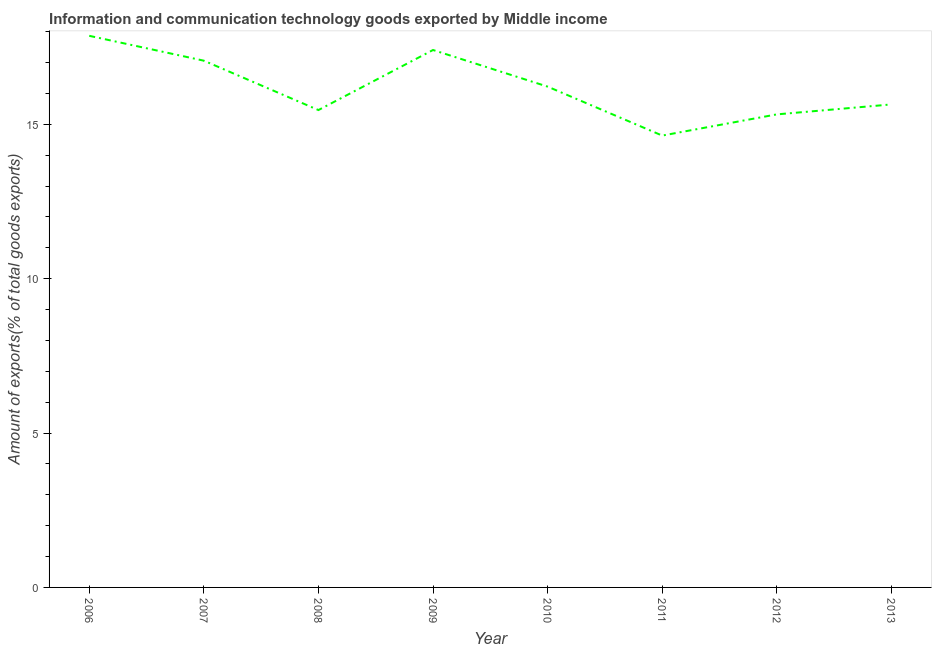What is the amount of ict goods exports in 2012?
Ensure brevity in your answer.  15.32. Across all years, what is the maximum amount of ict goods exports?
Make the answer very short. 17.86. Across all years, what is the minimum amount of ict goods exports?
Provide a succinct answer. 14.63. In which year was the amount of ict goods exports minimum?
Provide a succinct answer. 2011. What is the sum of the amount of ict goods exports?
Offer a very short reply. 129.61. What is the difference between the amount of ict goods exports in 2006 and 2010?
Keep it short and to the point. 1.65. What is the average amount of ict goods exports per year?
Your answer should be very brief. 16.2. What is the median amount of ict goods exports?
Provide a succinct answer. 15.93. Do a majority of the years between 2009 and 2012 (inclusive) have amount of ict goods exports greater than 7 %?
Offer a very short reply. Yes. What is the ratio of the amount of ict goods exports in 2008 to that in 2011?
Offer a very short reply. 1.06. Is the difference between the amount of ict goods exports in 2006 and 2012 greater than the difference between any two years?
Offer a very short reply. No. What is the difference between the highest and the second highest amount of ict goods exports?
Your response must be concise. 0.46. Is the sum of the amount of ict goods exports in 2010 and 2013 greater than the maximum amount of ict goods exports across all years?
Provide a short and direct response. Yes. What is the difference between the highest and the lowest amount of ict goods exports?
Your response must be concise. 3.23. In how many years, is the amount of ict goods exports greater than the average amount of ict goods exports taken over all years?
Ensure brevity in your answer.  4. Does the amount of ict goods exports monotonically increase over the years?
Your response must be concise. No. How many years are there in the graph?
Ensure brevity in your answer.  8. What is the difference between two consecutive major ticks on the Y-axis?
Provide a succinct answer. 5. Does the graph contain any zero values?
Offer a very short reply. No. What is the title of the graph?
Keep it short and to the point. Information and communication technology goods exported by Middle income. What is the label or title of the X-axis?
Offer a very short reply. Year. What is the label or title of the Y-axis?
Provide a short and direct response. Amount of exports(% of total goods exports). What is the Amount of exports(% of total goods exports) in 2006?
Provide a short and direct response. 17.86. What is the Amount of exports(% of total goods exports) in 2007?
Offer a terse response. 17.06. What is the Amount of exports(% of total goods exports) in 2008?
Offer a very short reply. 15.46. What is the Amount of exports(% of total goods exports) in 2009?
Provide a short and direct response. 17.41. What is the Amount of exports(% of total goods exports) in 2010?
Your response must be concise. 16.22. What is the Amount of exports(% of total goods exports) in 2011?
Give a very brief answer. 14.63. What is the Amount of exports(% of total goods exports) of 2012?
Your answer should be compact. 15.32. What is the Amount of exports(% of total goods exports) of 2013?
Make the answer very short. 15.64. What is the difference between the Amount of exports(% of total goods exports) in 2006 and 2007?
Ensure brevity in your answer.  0.81. What is the difference between the Amount of exports(% of total goods exports) in 2006 and 2008?
Your answer should be compact. 2.4. What is the difference between the Amount of exports(% of total goods exports) in 2006 and 2009?
Provide a short and direct response. 0.46. What is the difference between the Amount of exports(% of total goods exports) in 2006 and 2010?
Your answer should be very brief. 1.65. What is the difference between the Amount of exports(% of total goods exports) in 2006 and 2011?
Offer a terse response. 3.23. What is the difference between the Amount of exports(% of total goods exports) in 2006 and 2012?
Make the answer very short. 2.54. What is the difference between the Amount of exports(% of total goods exports) in 2006 and 2013?
Your answer should be compact. 2.22. What is the difference between the Amount of exports(% of total goods exports) in 2007 and 2008?
Give a very brief answer. 1.6. What is the difference between the Amount of exports(% of total goods exports) in 2007 and 2009?
Provide a short and direct response. -0.35. What is the difference between the Amount of exports(% of total goods exports) in 2007 and 2010?
Provide a short and direct response. 0.84. What is the difference between the Amount of exports(% of total goods exports) in 2007 and 2011?
Provide a succinct answer. 2.43. What is the difference between the Amount of exports(% of total goods exports) in 2007 and 2012?
Ensure brevity in your answer.  1.74. What is the difference between the Amount of exports(% of total goods exports) in 2007 and 2013?
Give a very brief answer. 1.42. What is the difference between the Amount of exports(% of total goods exports) in 2008 and 2009?
Ensure brevity in your answer.  -1.94. What is the difference between the Amount of exports(% of total goods exports) in 2008 and 2010?
Your answer should be very brief. -0.76. What is the difference between the Amount of exports(% of total goods exports) in 2008 and 2011?
Give a very brief answer. 0.83. What is the difference between the Amount of exports(% of total goods exports) in 2008 and 2012?
Provide a short and direct response. 0.14. What is the difference between the Amount of exports(% of total goods exports) in 2008 and 2013?
Your response must be concise. -0.18. What is the difference between the Amount of exports(% of total goods exports) in 2009 and 2010?
Ensure brevity in your answer.  1.19. What is the difference between the Amount of exports(% of total goods exports) in 2009 and 2011?
Make the answer very short. 2.77. What is the difference between the Amount of exports(% of total goods exports) in 2009 and 2012?
Make the answer very short. 2.09. What is the difference between the Amount of exports(% of total goods exports) in 2009 and 2013?
Provide a succinct answer. 1.76. What is the difference between the Amount of exports(% of total goods exports) in 2010 and 2011?
Keep it short and to the point. 1.59. What is the difference between the Amount of exports(% of total goods exports) in 2010 and 2012?
Your answer should be very brief. 0.9. What is the difference between the Amount of exports(% of total goods exports) in 2010 and 2013?
Offer a terse response. 0.58. What is the difference between the Amount of exports(% of total goods exports) in 2011 and 2012?
Your answer should be compact. -0.69. What is the difference between the Amount of exports(% of total goods exports) in 2011 and 2013?
Your answer should be compact. -1.01. What is the difference between the Amount of exports(% of total goods exports) in 2012 and 2013?
Give a very brief answer. -0.32. What is the ratio of the Amount of exports(% of total goods exports) in 2006 to that in 2007?
Ensure brevity in your answer.  1.05. What is the ratio of the Amount of exports(% of total goods exports) in 2006 to that in 2008?
Provide a short and direct response. 1.16. What is the ratio of the Amount of exports(% of total goods exports) in 2006 to that in 2009?
Your response must be concise. 1.03. What is the ratio of the Amount of exports(% of total goods exports) in 2006 to that in 2010?
Keep it short and to the point. 1.1. What is the ratio of the Amount of exports(% of total goods exports) in 2006 to that in 2011?
Give a very brief answer. 1.22. What is the ratio of the Amount of exports(% of total goods exports) in 2006 to that in 2012?
Make the answer very short. 1.17. What is the ratio of the Amount of exports(% of total goods exports) in 2006 to that in 2013?
Provide a short and direct response. 1.14. What is the ratio of the Amount of exports(% of total goods exports) in 2007 to that in 2008?
Your answer should be compact. 1.1. What is the ratio of the Amount of exports(% of total goods exports) in 2007 to that in 2009?
Your response must be concise. 0.98. What is the ratio of the Amount of exports(% of total goods exports) in 2007 to that in 2010?
Provide a succinct answer. 1.05. What is the ratio of the Amount of exports(% of total goods exports) in 2007 to that in 2011?
Provide a succinct answer. 1.17. What is the ratio of the Amount of exports(% of total goods exports) in 2007 to that in 2012?
Your response must be concise. 1.11. What is the ratio of the Amount of exports(% of total goods exports) in 2007 to that in 2013?
Provide a succinct answer. 1.09. What is the ratio of the Amount of exports(% of total goods exports) in 2008 to that in 2009?
Your response must be concise. 0.89. What is the ratio of the Amount of exports(% of total goods exports) in 2008 to that in 2010?
Your answer should be compact. 0.95. What is the ratio of the Amount of exports(% of total goods exports) in 2008 to that in 2011?
Your response must be concise. 1.06. What is the ratio of the Amount of exports(% of total goods exports) in 2008 to that in 2012?
Give a very brief answer. 1.01. What is the ratio of the Amount of exports(% of total goods exports) in 2009 to that in 2010?
Offer a terse response. 1.07. What is the ratio of the Amount of exports(% of total goods exports) in 2009 to that in 2011?
Keep it short and to the point. 1.19. What is the ratio of the Amount of exports(% of total goods exports) in 2009 to that in 2012?
Give a very brief answer. 1.14. What is the ratio of the Amount of exports(% of total goods exports) in 2009 to that in 2013?
Provide a succinct answer. 1.11. What is the ratio of the Amount of exports(% of total goods exports) in 2010 to that in 2011?
Make the answer very short. 1.11. What is the ratio of the Amount of exports(% of total goods exports) in 2010 to that in 2012?
Keep it short and to the point. 1.06. What is the ratio of the Amount of exports(% of total goods exports) in 2011 to that in 2012?
Keep it short and to the point. 0.95. What is the ratio of the Amount of exports(% of total goods exports) in 2011 to that in 2013?
Offer a terse response. 0.94. 